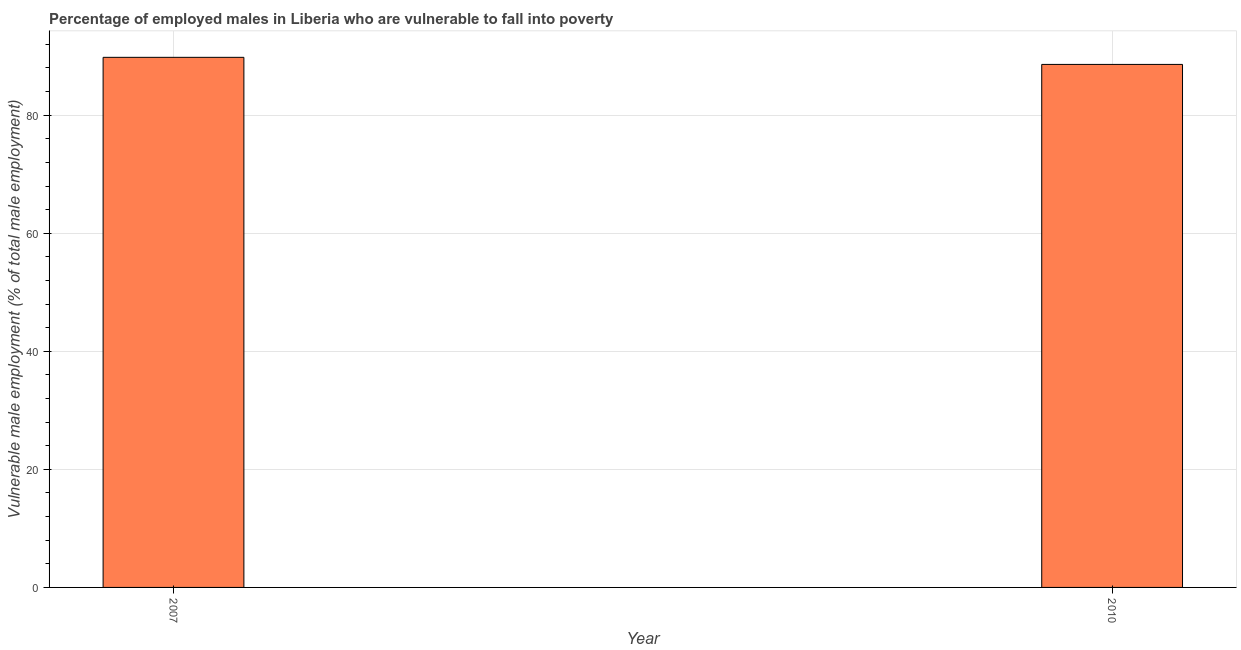Does the graph contain any zero values?
Keep it short and to the point. No. What is the title of the graph?
Provide a short and direct response. Percentage of employed males in Liberia who are vulnerable to fall into poverty. What is the label or title of the X-axis?
Make the answer very short. Year. What is the label or title of the Y-axis?
Offer a very short reply. Vulnerable male employment (% of total male employment). What is the percentage of employed males who are vulnerable to fall into poverty in 2010?
Your response must be concise. 88.6. Across all years, what is the maximum percentage of employed males who are vulnerable to fall into poverty?
Offer a very short reply. 89.8. Across all years, what is the minimum percentage of employed males who are vulnerable to fall into poverty?
Ensure brevity in your answer.  88.6. What is the sum of the percentage of employed males who are vulnerable to fall into poverty?
Your response must be concise. 178.4. What is the average percentage of employed males who are vulnerable to fall into poverty per year?
Ensure brevity in your answer.  89.2. What is the median percentage of employed males who are vulnerable to fall into poverty?
Make the answer very short. 89.2. In how many years, is the percentage of employed males who are vulnerable to fall into poverty greater than 16 %?
Your response must be concise. 2. Do a majority of the years between 2007 and 2010 (inclusive) have percentage of employed males who are vulnerable to fall into poverty greater than 64 %?
Offer a very short reply. Yes. In how many years, is the percentage of employed males who are vulnerable to fall into poverty greater than the average percentage of employed males who are vulnerable to fall into poverty taken over all years?
Provide a succinct answer. 1. How many bars are there?
Your answer should be very brief. 2. Are all the bars in the graph horizontal?
Make the answer very short. No. What is the difference between two consecutive major ticks on the Y-axis?
Your answer should be compact. 20. What is the Vulnerable male employment (% of total male employment) in 2007?
Give a very brief answer. 89.8. What is the Vulnerable male employment (% of total male employment) of 2010?
Your answer should be compact. 88.6. What is the difference between the Vulnerable male employment (% of total male employment) in 2007 and 2010?
Offer a terse response. 1.2. 